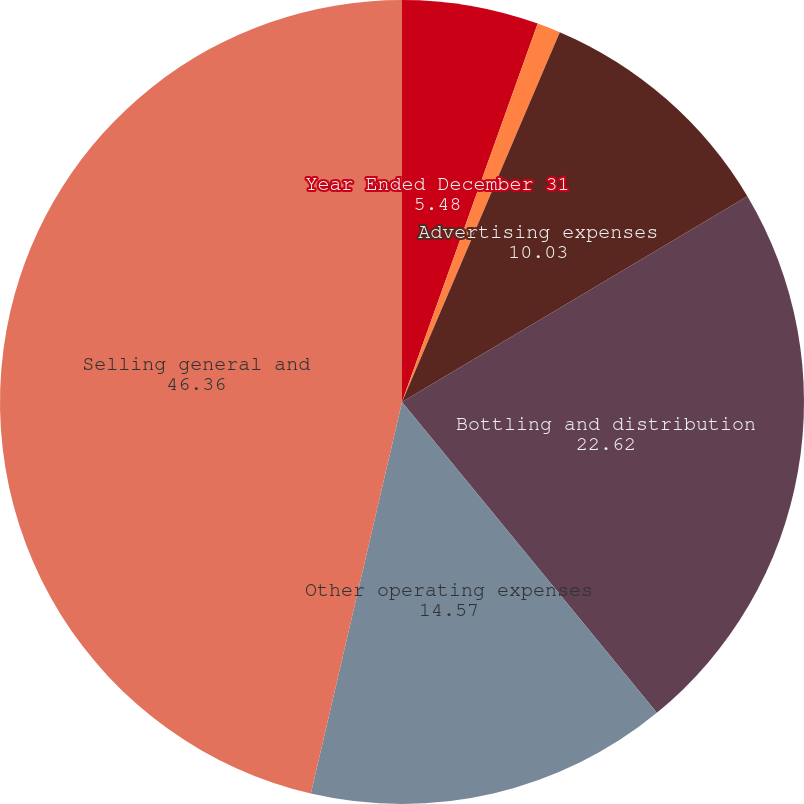Convert chart to OTSL. <chart><loc_0><loc_0><loc_500><loc_500><pie_chart><fcel>Year Ended December 31<fcel>Stock-based compensation<fcel>Advertising expenses<fcel>Bottling and distribution<fcel>Other operating expenses<fcel>Selling general and<nl><fcel>5.48%<fcel>0.94%<fcel>10.03%<fcel>22.62%<fcel>14.57%<fcel>46.36%<nl></chart> 